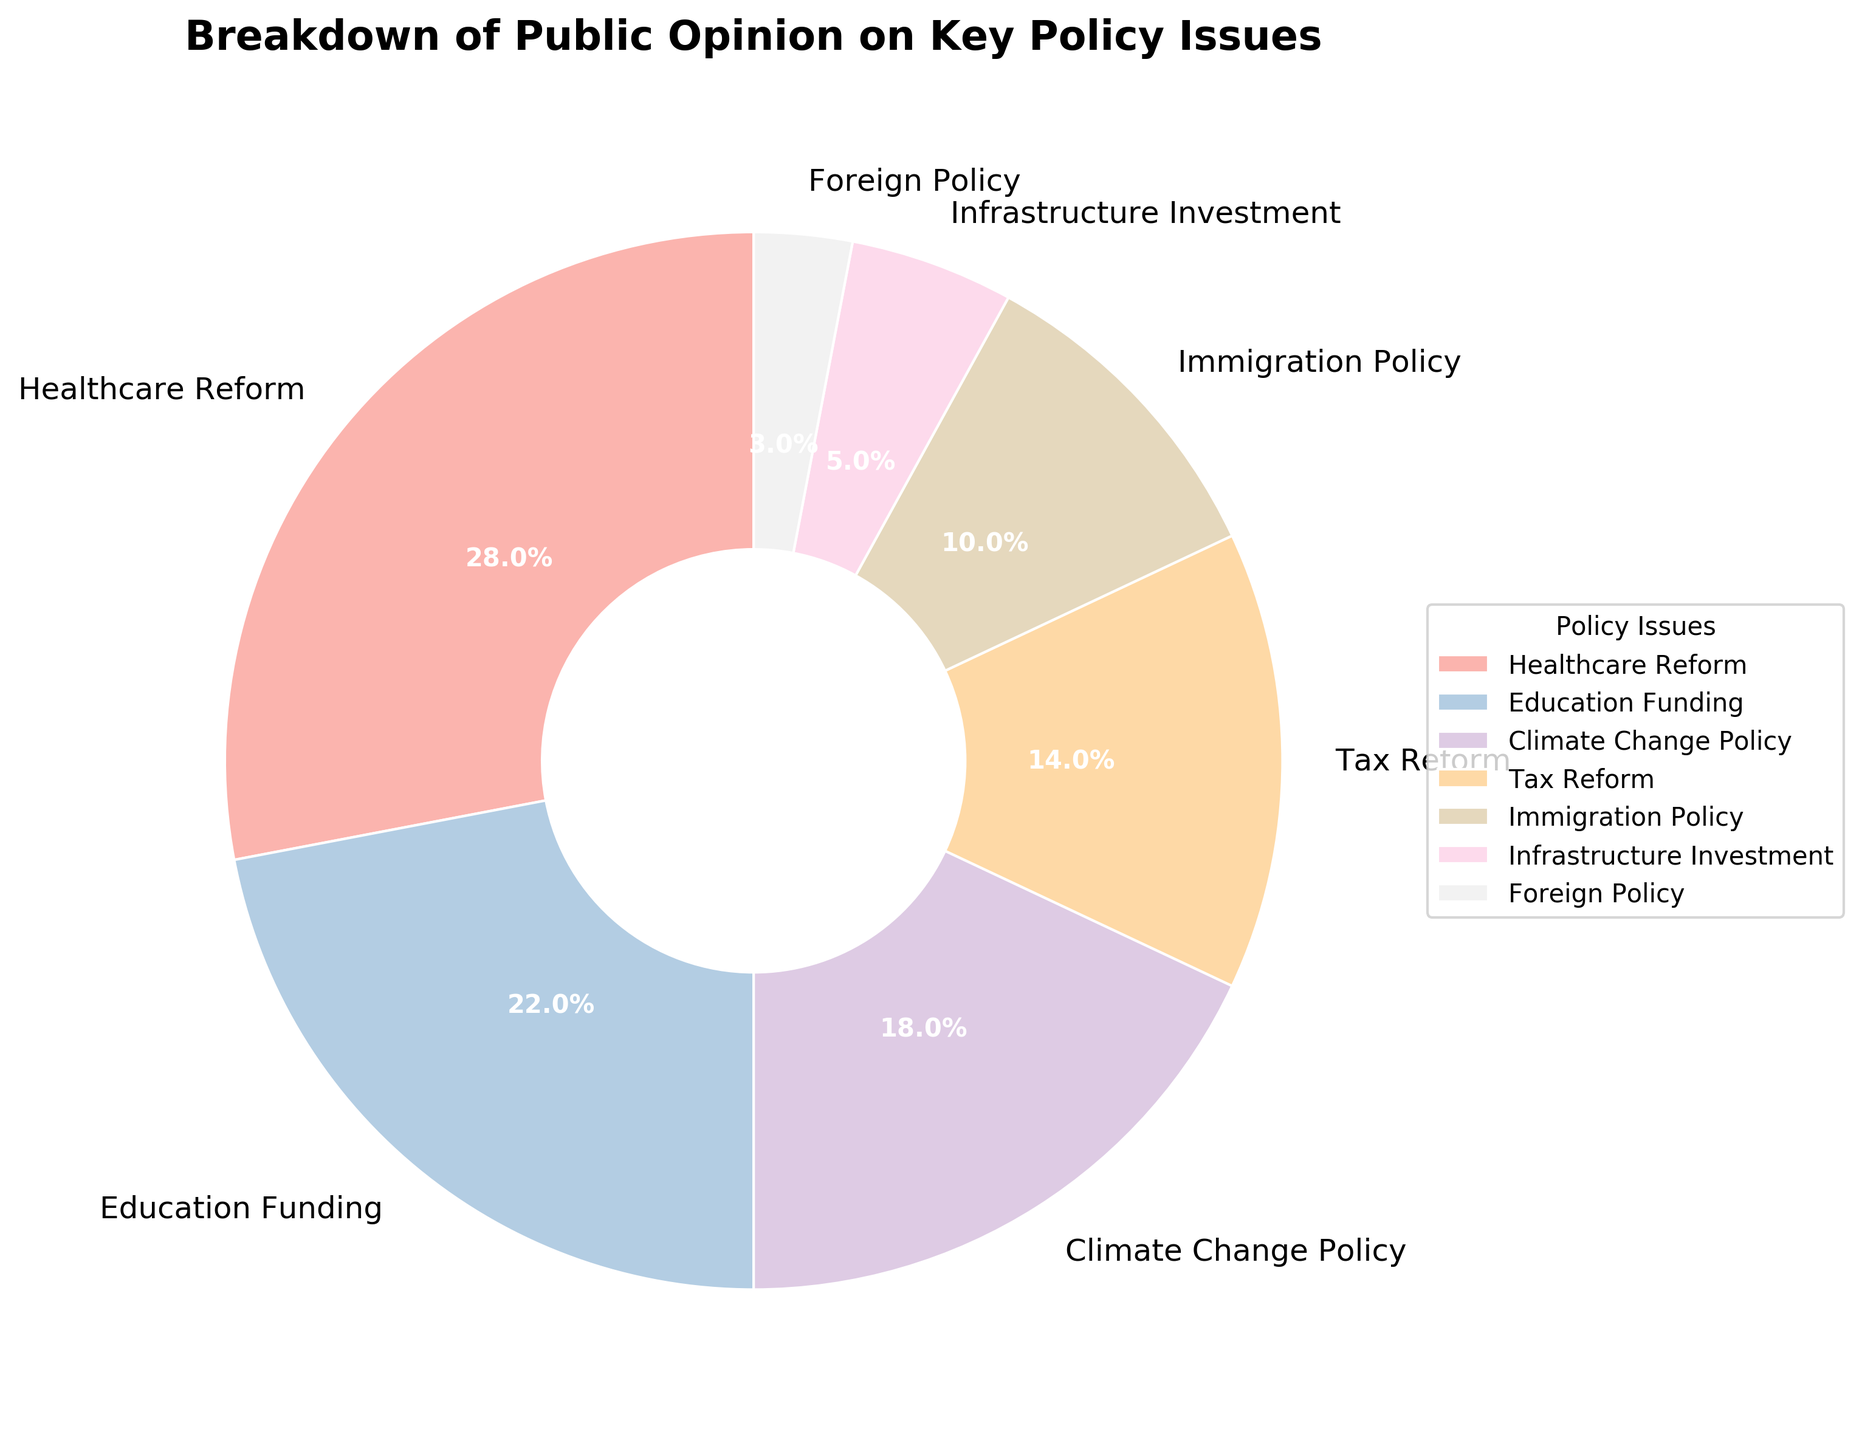Which policy issue has the highest percentage of public opinion? To find the policy issue with the highest percentage of public opinion, look for the segment of the pie chart with the largest labeled percentage. In this case, "Healthcare Reform" is labeled with 28%, which is the highest percentage.
Answer: Healthcare Reform How many percentage points is Climate Change Policy less than Healthcare Reform? First, identify the percentages for Climate Change Policy (18%) and Healthcare Reform (28%). Then, subtract the percentage of Climate Change Policy from Healthcare Reform to find the difference: 28 - 18 = 10.
Answer: 10 Which two policy issues have the smallest percentage of public opinion combined? Identify the two smallest percentages on the pie chart, which are Infrastructure Investment (5%) and Foreign Policy (3%). Add these percentages together: 5 + 3 = 8.
Answer: Infrastructure Investment and Foreign Policy Is the percentage of public opinion for Tax Reform greater than the combined percentages for Immigration Policy and Foreign Policy? First, find the percentage for Tax Reform (14%). Then, sum the percentages for Immigration Policy (10%) and Foreign Policy (3%): 10 + 3 = 13. Compare the two sums: 14 is greater than 13.
Answer: Yes Which segment of the pie chart is represented in a unique color compared to others? Examine the color distribution in the pie chart. It appears that each segment has a unique pastel color. Thus, all segments are represented in different colors.
Answer: All segments have unique colors What is the total percentage of public opinion for Education Funding and Climate Change Policy? Identify the percentages for Education Funding (22%) and Climate Change Policy (18%). Add these percentages together: 22 + 18 = 40.
Answer: 40 Is the segment for Immigration Policy larger or smaller than the segment for Infrastructure Investment? Compare the percentages of Immigration Policy (10%) and Infrastructure Investment (5%). Clearly, 10% is larger than 5%.
Answer: Larger By how many percentage points does Education Funding exceed Foreign Policy? First, identify the percentages for Education Funding (22%) and Foreign Policy (3%). Subtract the percentage of Foreign Policy from Education Funding: 22 - 3 = 19.
Answer: 19 